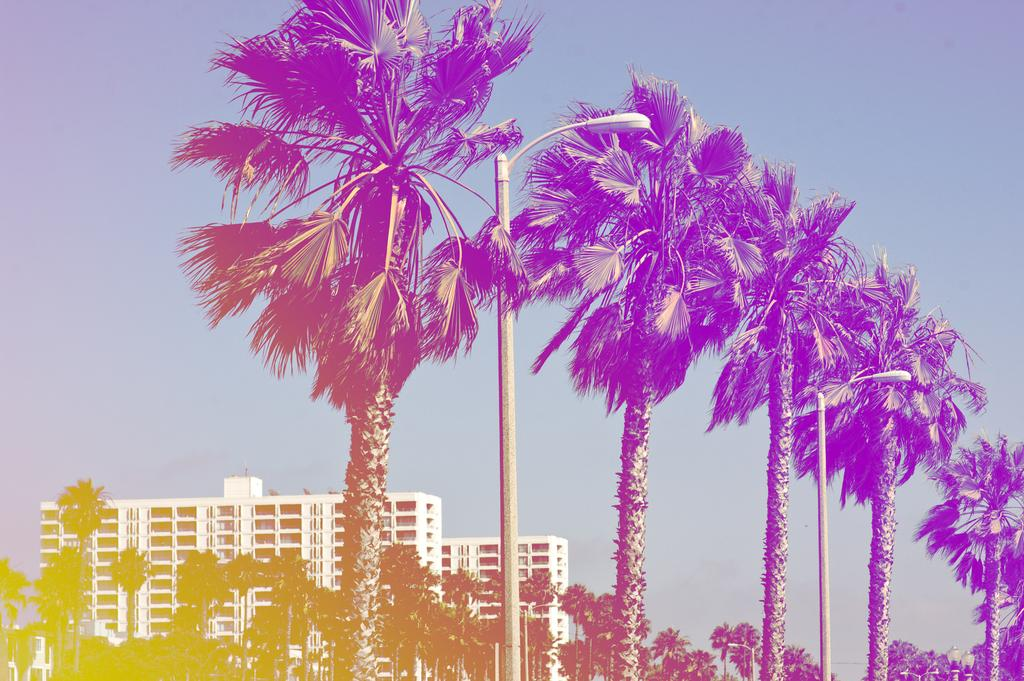What is located in the center of the image? There are trees and a street light in the center of the image. What can be seen in the background of the image? There are buildings, trees, and the sky visible in the background of the image. What type of cheese is hanging from the trees in the image? There is no cheese present in the image; it features trees and a street light in the center, with buildings, trees, and the sky visible in the background. How many wool-covered frogs are sitting on the street light in the image? There are no frogs, let alone wool-covered ones, present on the street light in the image. 